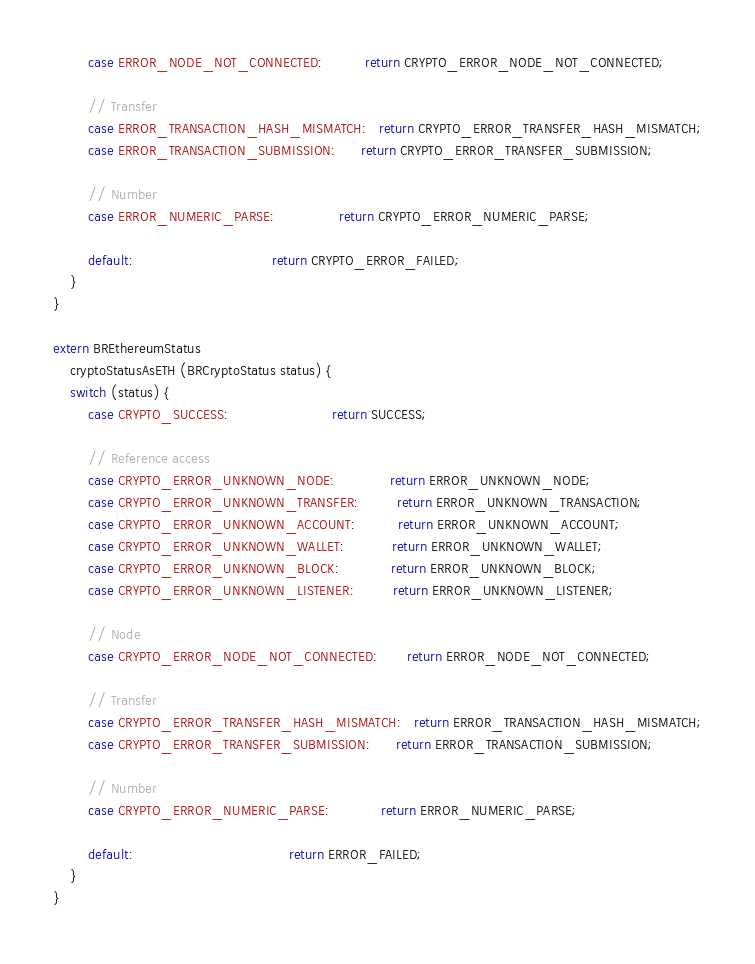<code> <loc_0><loc_0><loc_500><loc_500><_C_>        case ERROR_NODE_NOT_CONNECTED:          return CRYPTO_ERROR_NODE_NOT_CONNECTED;

        // Transfer
        case ERROR_TRANSACTION_HASH_MISMATCH:   return CRYPTO_ERROR_TRANSFER_HASH_MISMATCH;
        case ERROR_TRANSACTION_SUBMISSION:      return CRYPTO_ERROR_TRANSFER_SUBMISSION;

        // Number
        case ERROR_NUMERIC_PARSE:               return CRYPTO_ERROR_NUMERIC_PARSE;

        default:                                return CRYPTO_ERROR_FAILED;
    }
}

extern BREthereumStatus
    cryptoStatusAsETH (BRCryptoStatus status) {
    switch (status) {
        case CRYPTO_SUCCESS:                        return SUCCESS;

        // Reference access
        case CRYPTO_ERROR_UNKNOWN_NODE:             return ERROR_UNKNOWN_NODE;
        case CRYPTO_ERROR_UNKNOWN_TRANSFER:         return ERROR_UNKNOWN_TRANSACTION;
        case CRYPTO_ERROR_UNKNOWN_ACCOUNT:          return ERROR_UNKNOWN_ACCOUNT;
        case CRYPTO_ERROR_UNKNOWN_WALLET:           return ERROR_UNKNOWN_WALLET;
        case CRYPTO_ERROR_UNKNOWN_BLOCK:            return ERROR_UNKNOWN_BLOCK;
        case CRYPTO_ERROR_UNKNOWN_LISTENER:         return ERROR_UNKNOWN_LISTENER;

        // Node
        case CRYPTO_ERROR_NODE_NOT_CONNECTED:       return ERROR_NODE_NOT_CONNECTED;

        // Transfer
        case CRYPTO_ERROR_TRANSFER_HASH_MISMATCH:   return ERROR_TRANSACTION_HASH_MISMATCH;
        case CRYPTO_ERROR_TRANSFER_SUBMISSION:      return ERROR_TRANSACTION_SUBMISSION;

        // Number
        case CRYPTO_ERROR_NUMERIC_PARSE:            return ERROR_NUMERIC_PARSE;

        default:                                    return ERROR_FAILED;
    }
}
</code> 